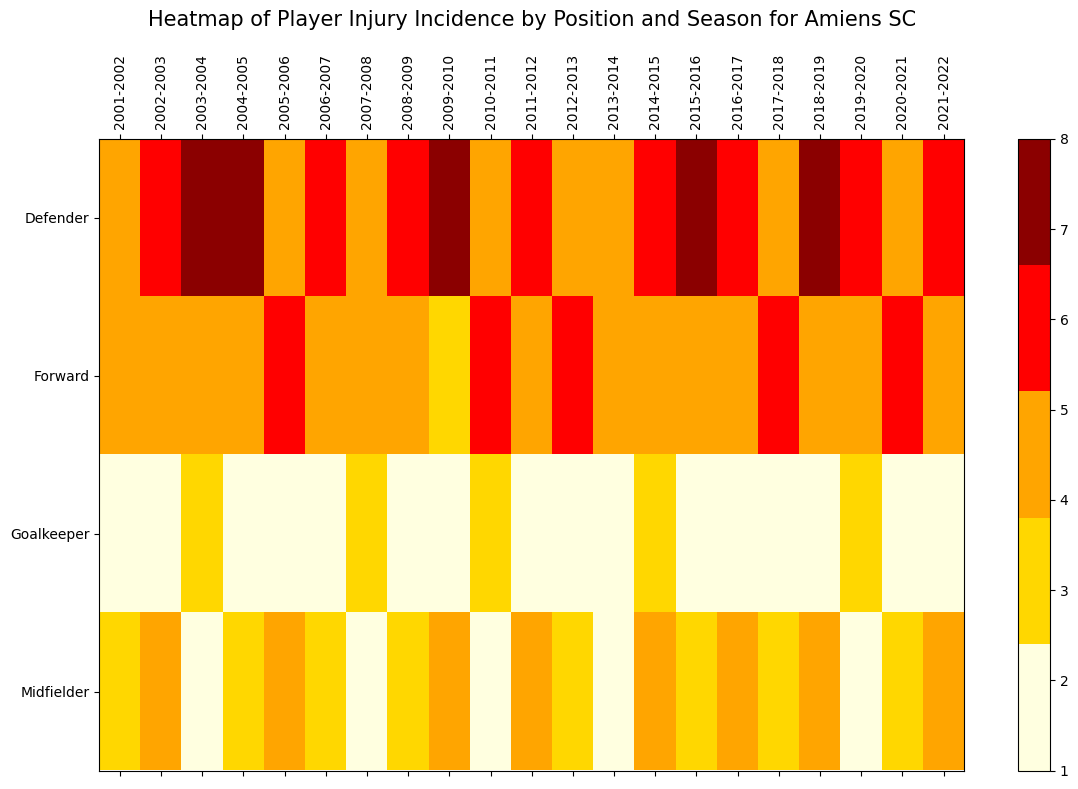Which position had the highest number of injuries in the 2004-2005 season? Look at the 2004-2005 column and compare the values of injuries for Goalkeeper, Defender, Midfielder, and Forward. The highest number is 8 for Defender.
Answer: Defender How many total injuries occurred among Midfielders from 2001-2002 to 2004-2005? Add up the number of injuries for Midfielders over the given seasons: 3 (2001-2002) + 4 (2002-2003) + 2 (2003-2004) + 3 (2004-2005) = 12
Answer: 12 Which season had the lowest number of injuries for Goalkeepers? Check the Goalkeeper row across all seasons for the lowest value. The lowest count is 1, which appears in the 2002-2003, 2009-2010, 2011-2012, 2013-2014, 2016-2017, 2018-2019, and 2021-2022 seasons.
Answer: 2002-2003, 2009-2010, 2011-2012, 2013-2014, 2016-2017, 2018-2019, 2021-2022 Did more injuries occur for Forwards in the 2002-2003 season or the 2006-2007 season? Compare the number of injuries for Forwards in the given seasons. There are 5 injuries in 2002-2003 and 5 injuries in 2006-2007. Both are the same.
Answer: Both equally Which position had the most consistent injury count over the seasons in terms of visual color uniformity? Observe the heatmap colors for each position and check for the most consistent color pattern. The Midfielders predominantly stay within the lighter color range (lightyellow and gold).
Answer: Midfielder Calculate the average number of injuries for Defenders between 2008-2009 and 2011-2012. Add the injuries for Defenders in these seasons and divide by the number of seasons: (6 (2008-2009) + 7 (2009-2010) + 5 (2010-2011) + 6 (2011-2012)) / 4 = 24 / 4 = 6
Answer: 6 Which season shows the highest total number of injuries across all positions? Sum the injuries for all positions in each season and compare. 2004-2005 has the highest count: 2 (Goalkeeper) + 8 (Defender) + 3 (Midfielder) + 5 (Forward) = 18
Answer: 2004-2005 Which position has the most varying injury count over the given seasons? Observe the fluctuation in colors for each position across seasons. Defenders fluctuate the most, ranging from lightyellow to darkred
Answer: Defender 